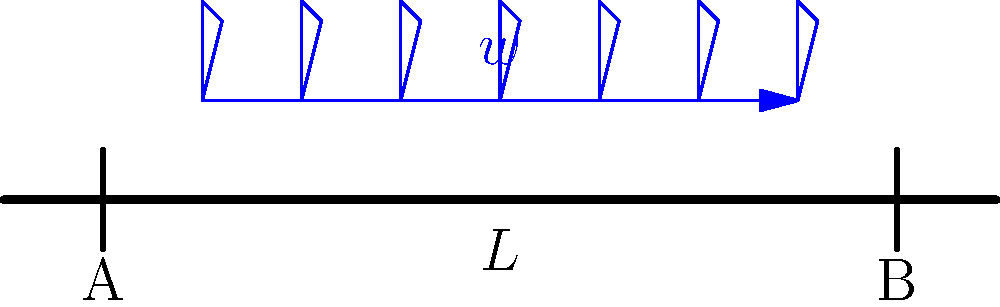A simply supported beam of length $L$ is subjected to a uniformly distributed load $w$ along its entire length. At which point(s) along the beam will the bending moment be maximum, and what is the magnitude of this maximum bending moment in terms of $w$ and $L$? Let's approach this step-by-step:

1) For a simply supported beam with a uniformly distributed load, the reactions at the supports are equal and can be calculated as:

   $R_A = R_B = \frac{wL}{2}$

2) The bending moment at any point $x$ along the beam is given by:

   $M(x) = R_A \cdot x - w \cdot \frac{x^2}{2}$

3) To find the maximum bending moment, we need to differentiate $M(x)$ with respect to $x$ and set it to zero:

   $\frac{dM}{dx} = R_A - wx = 0$

4) Solving this equation:

   $R_A - wx = 0$
   $\frac{wL}{2} - wx = 0$
   $x = \frac{L}{2}$

5) This means the maximum bending moment occurs at the middle of the beam ($x = \frac{L}{2}$).

6) To find the magnitude of the maximum bending moment, we substitute $x = \frac{L}{2}$ into the bending moment equation:

   $M_{max} = R_A \cdot \frac{L}{2} - w \cdot \frac{(\frac{L}{2})^2}{2}$
   $M_{max} = \frac{wL}{2} \cdot \frac{L}{2} - w \cdot \frac{L^2}{8}$
   $M_{max} = \frac{wL^2}{4} - \frac{wL^2}{8} = \frac{wL^2}{8}$

Therefore, the maximum bending moment occurs at the middle of the beam and its magnitude is $\frac{wL^2}{8}$.
Answer: Middle of beam; $\frac{wL^2}{8}$ 